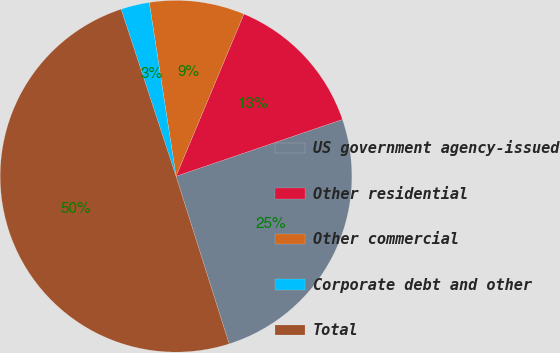<chart> <loc_0><loc_0><loc_500><loc_500><pie_chart><fcel>US government agency-issued<fcel>Other residential<fcel>Other commercial<fcel>Corporate debt and other<fcel>Total<nl><fcel>25.35%<fcel>13.46%<fcel>8.74%<fcel>2.62%<fcel>49.83%<nl></chart> 